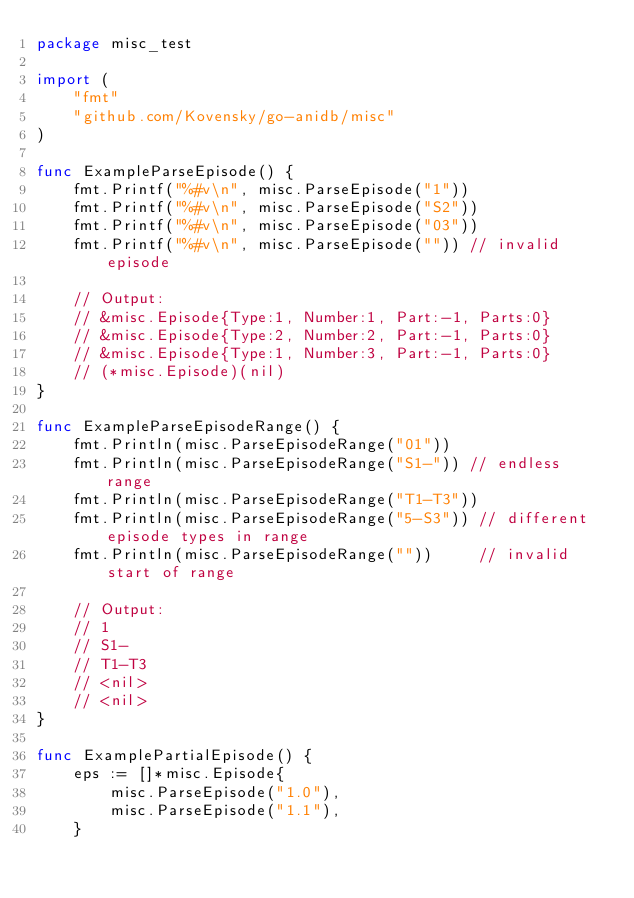<code> <loc_0><loc_0><loc_500><loc_500><_Go_>package misc_test

import (
	"fmt"
	"github.com/Kovensky/go-anidb/misc"
)

func ExampleParseEpisode() {
	fmt.Printf("%#v\n", misc.ParseEpisode("1"))
	fmt.Printf("%#v\n", misc.ParseEpisode("S2"))
	fmt.Printf("%#v\n", misc.ParseEpisode("03"))
	fmt.Printf("%#v\n", misc.ParseEpisode("")) // invalid episode

	// Output:
	// &misc.Episode{Type:1, Number:1, Part:-1, Parts:0}
	// &misc.Episode{Type:2, Number:2, Part:-1, Parts:0}
	// &misc.Episode{Type:1, Number:3, Part:-1, Parts:0}
	// (*misc.Episode)(nil)
}

func ExampleParseEpisodeRange() {
	fmt.Println(misc.ParseEpisodeRange("01"))
	fmt.Println(misc.ParseEpisodeRange("S1-")) // endless range
	fmt.Println(misc.ParseEpisodeRange("T1-T3"))
	fmt.Println(misc.ParseEpisodeRange("5-S3")) // different episode types in range
	fmt.Println(misc.ParseEpisodeRange(""))     // invalid start of range

	// Output:
	// 1
	// S1-
	// T1-T3
	// <nil>
	// <nil>
}

func ExamplePartialEpisode() {
	eps := []*misc.Episode{
		misc.ParseEpisode("1.0"),
		misc.ParseEpisode("1.1"),
	}</code> 